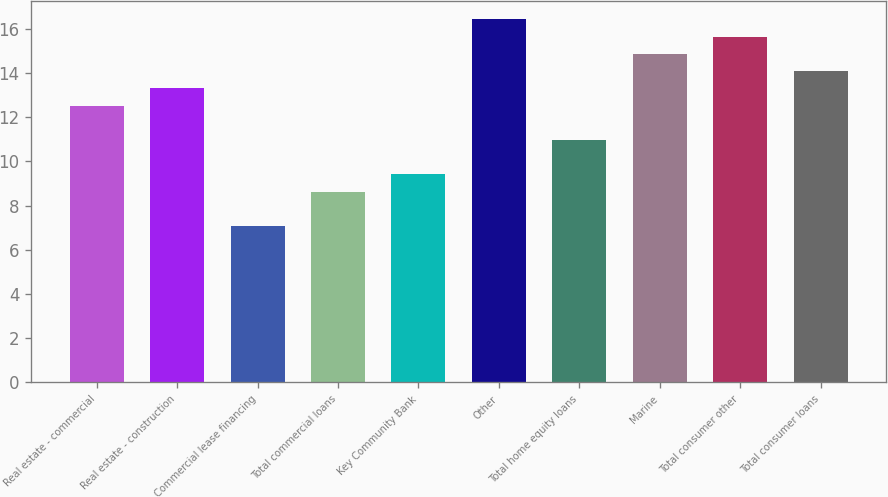Convert chart. <chart><loc_0><loc_0><loc_500><loc_500><bar_chart><fcel>Real estate - commercial<fcel>Real estate - construction<fcel>Commercial lease financing<fcel>Total commercial loans<fcel>Key Community Bank<fcel>Other<fcel>Total home equity loans<fcel>Marine<fcel>Total consumer other<fcel>Total consumer loans<nl><fcel>12.53<fcel>13.31<fcel>7.07<fcel>8.63<fcel>9.41<fcel>16.43<fcel>10.97<fcel>14.87<fcel>15.65<fcel>14.09<nl></chart> 